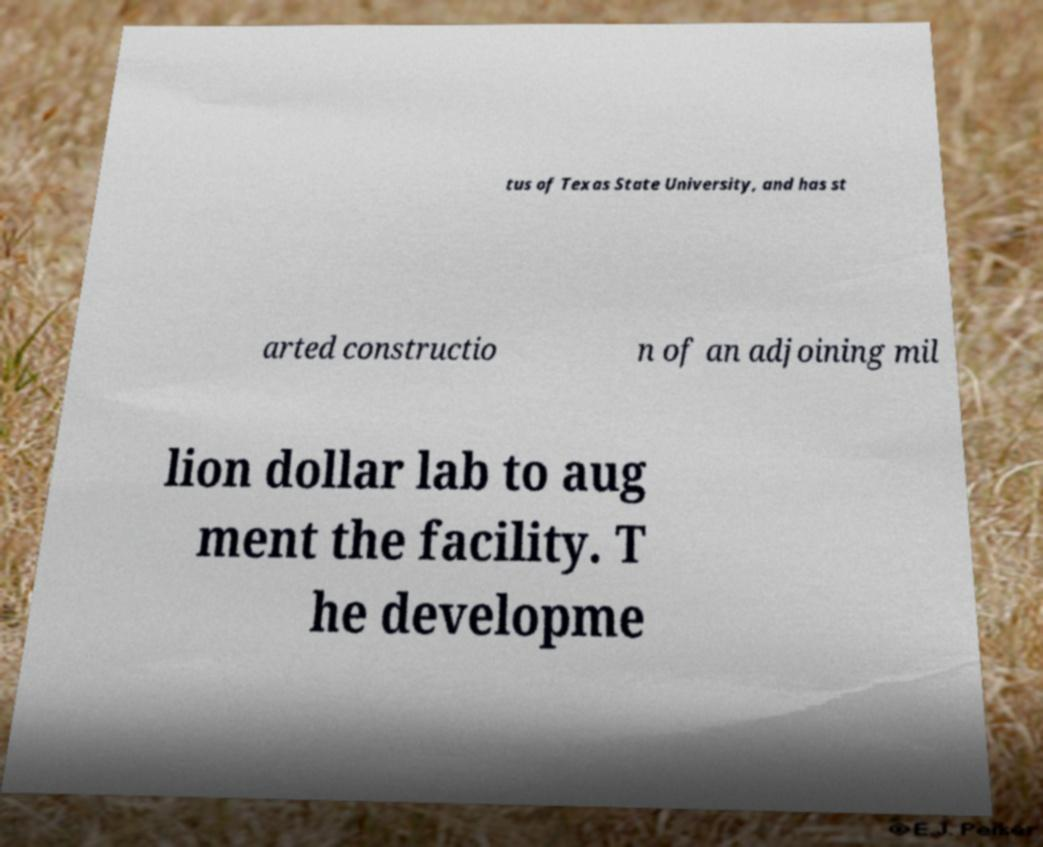Could you extract and type out the text from this image? tus of Texas State University, and has st arted constructio n of an adjoining mil lion dollar lab to aug ment the facility. T he developme 